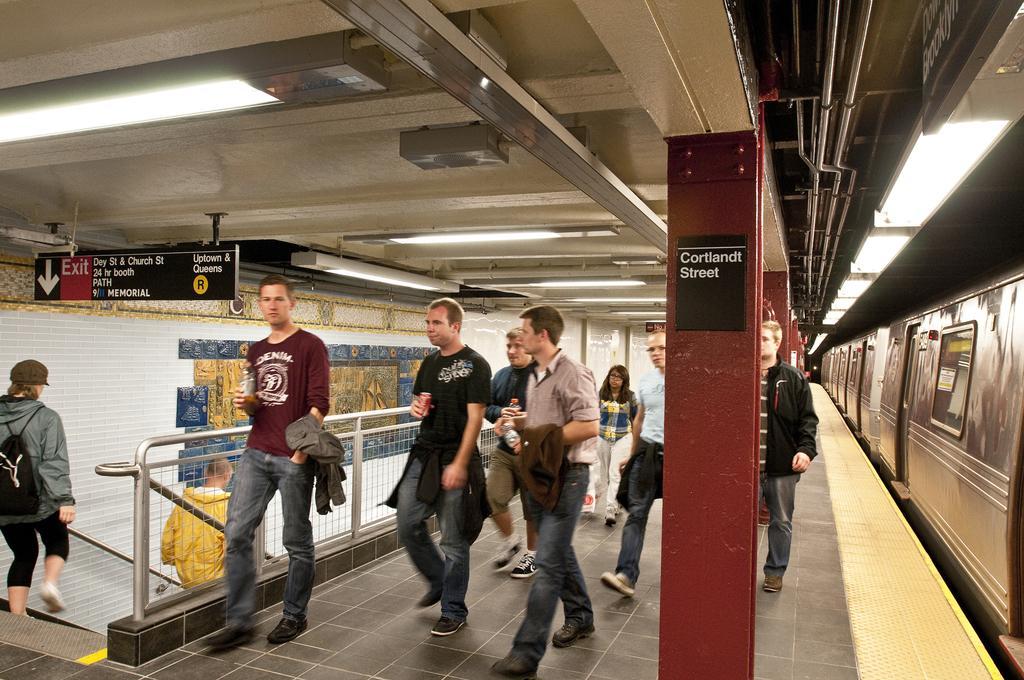In one or two sentences, can you explain what this image depicts? In this image we can see train with windows and doors on the right side. On the ceiling there are lights. Also there are pillars and boards with something written. There are many people. Also there is a railing. And there are steps with handle. And there is a wall with some painting. 